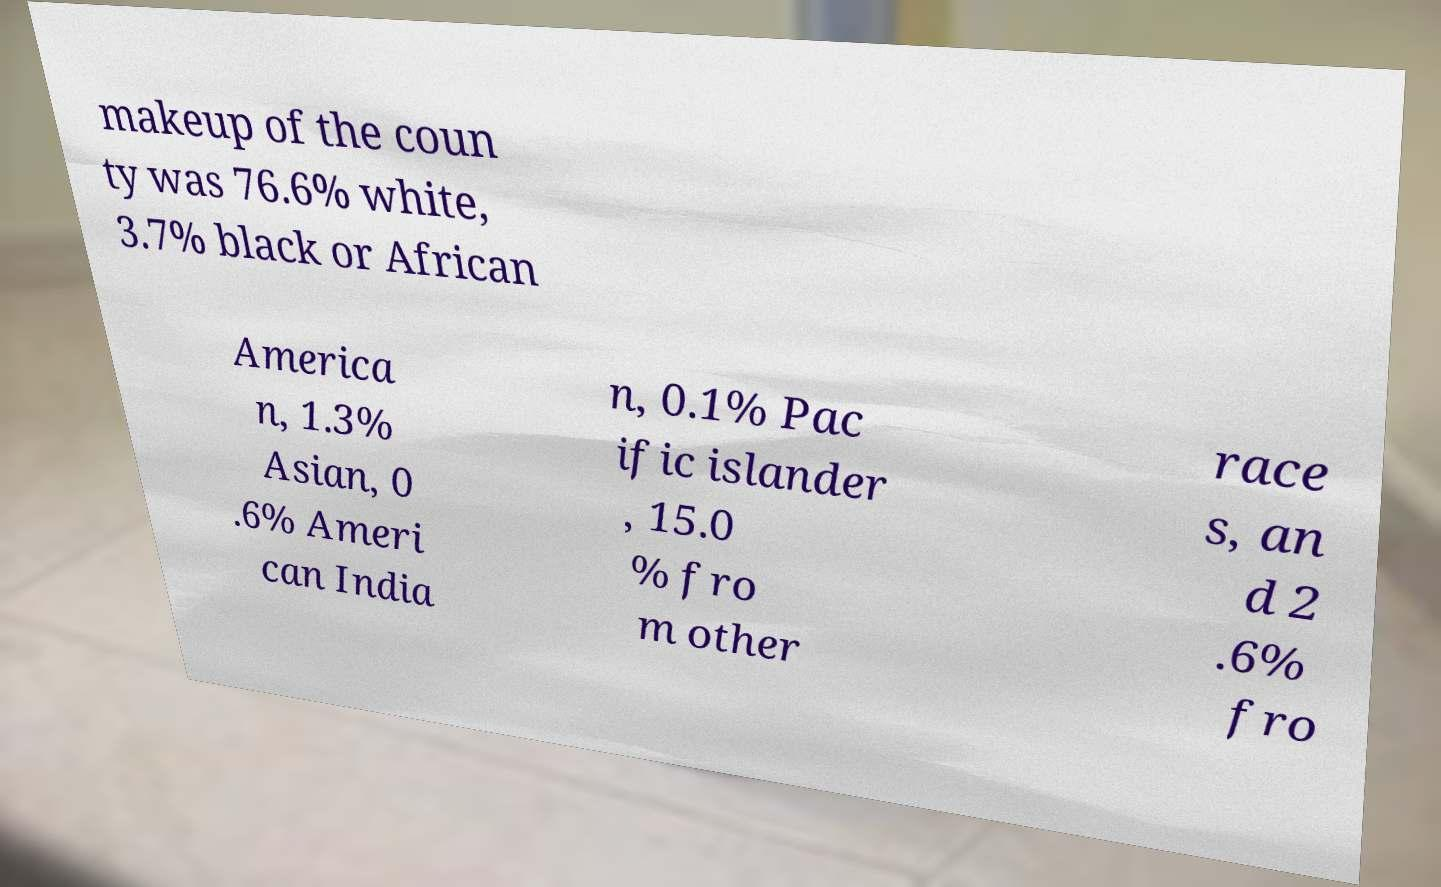Could you extract and type out the text from this image? makeup of the coun ty was 76.6% white, 3.7% black or African America n, 1.3% Asian, 0 .6% Ameri can India n, 0.1% Pac ific islander , 15.0 % fro m other race s, an d 2 .6% fro 